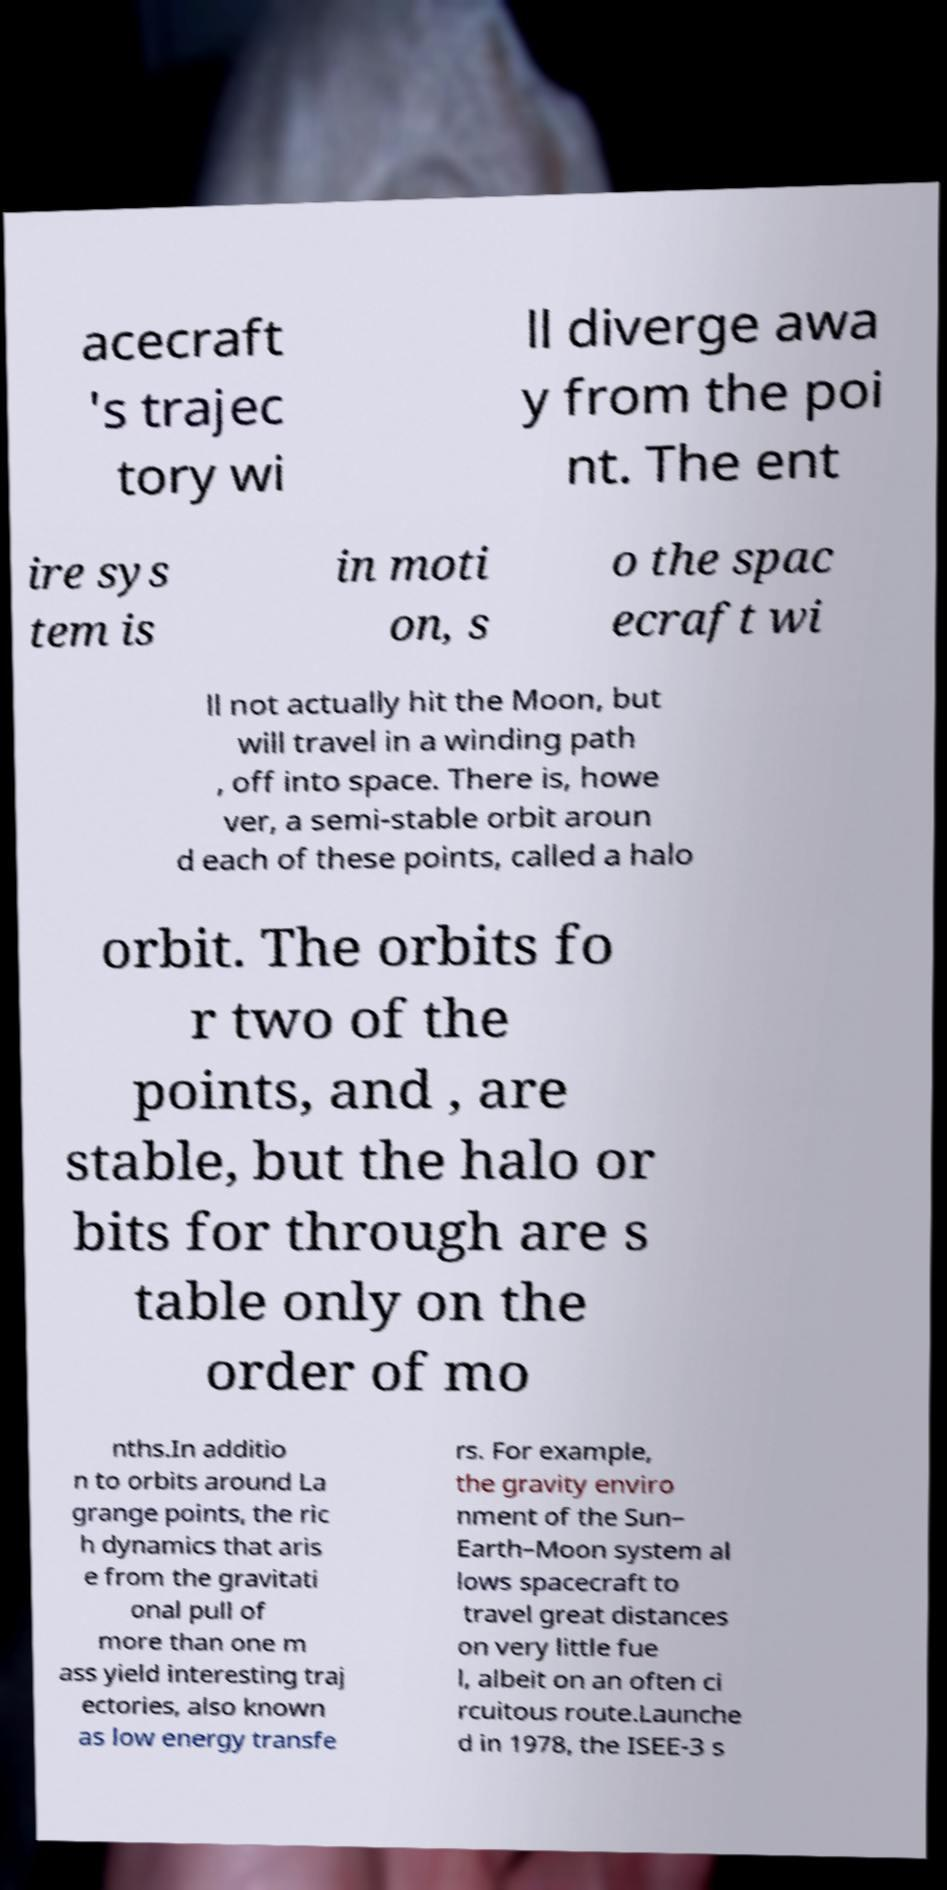Could you assist in decoding the text presented in this image and type it out clearly? acecraft 's trajec tory wi ll diverge awa y from the poi nt. The ent ire sys tem is in moti on, s o the spac ecraft wi ll not actually hit the Moon, but will travel in a winding path , off into space. There is, howe ver, a semi-stable orbit aroun d each of these points, called a halo orbit. The orbits fo r two of the points, and , are stable, but the halo or bits for through are s table only on the order of mo nths.In additio n to orbits around La grange points, the ric h dynamics that aris e from the gravitati onal pull of more than one m ass yield interesting traj ectories, also known as low energy transfe rs. For example, the gravity enviro nment of the Sun– Earth–Moon system al lows spacecraft to travel great distances on very little fue l, albeit on an often ci rcuitous route.Launche d in 1978, the ISEE-3 s 